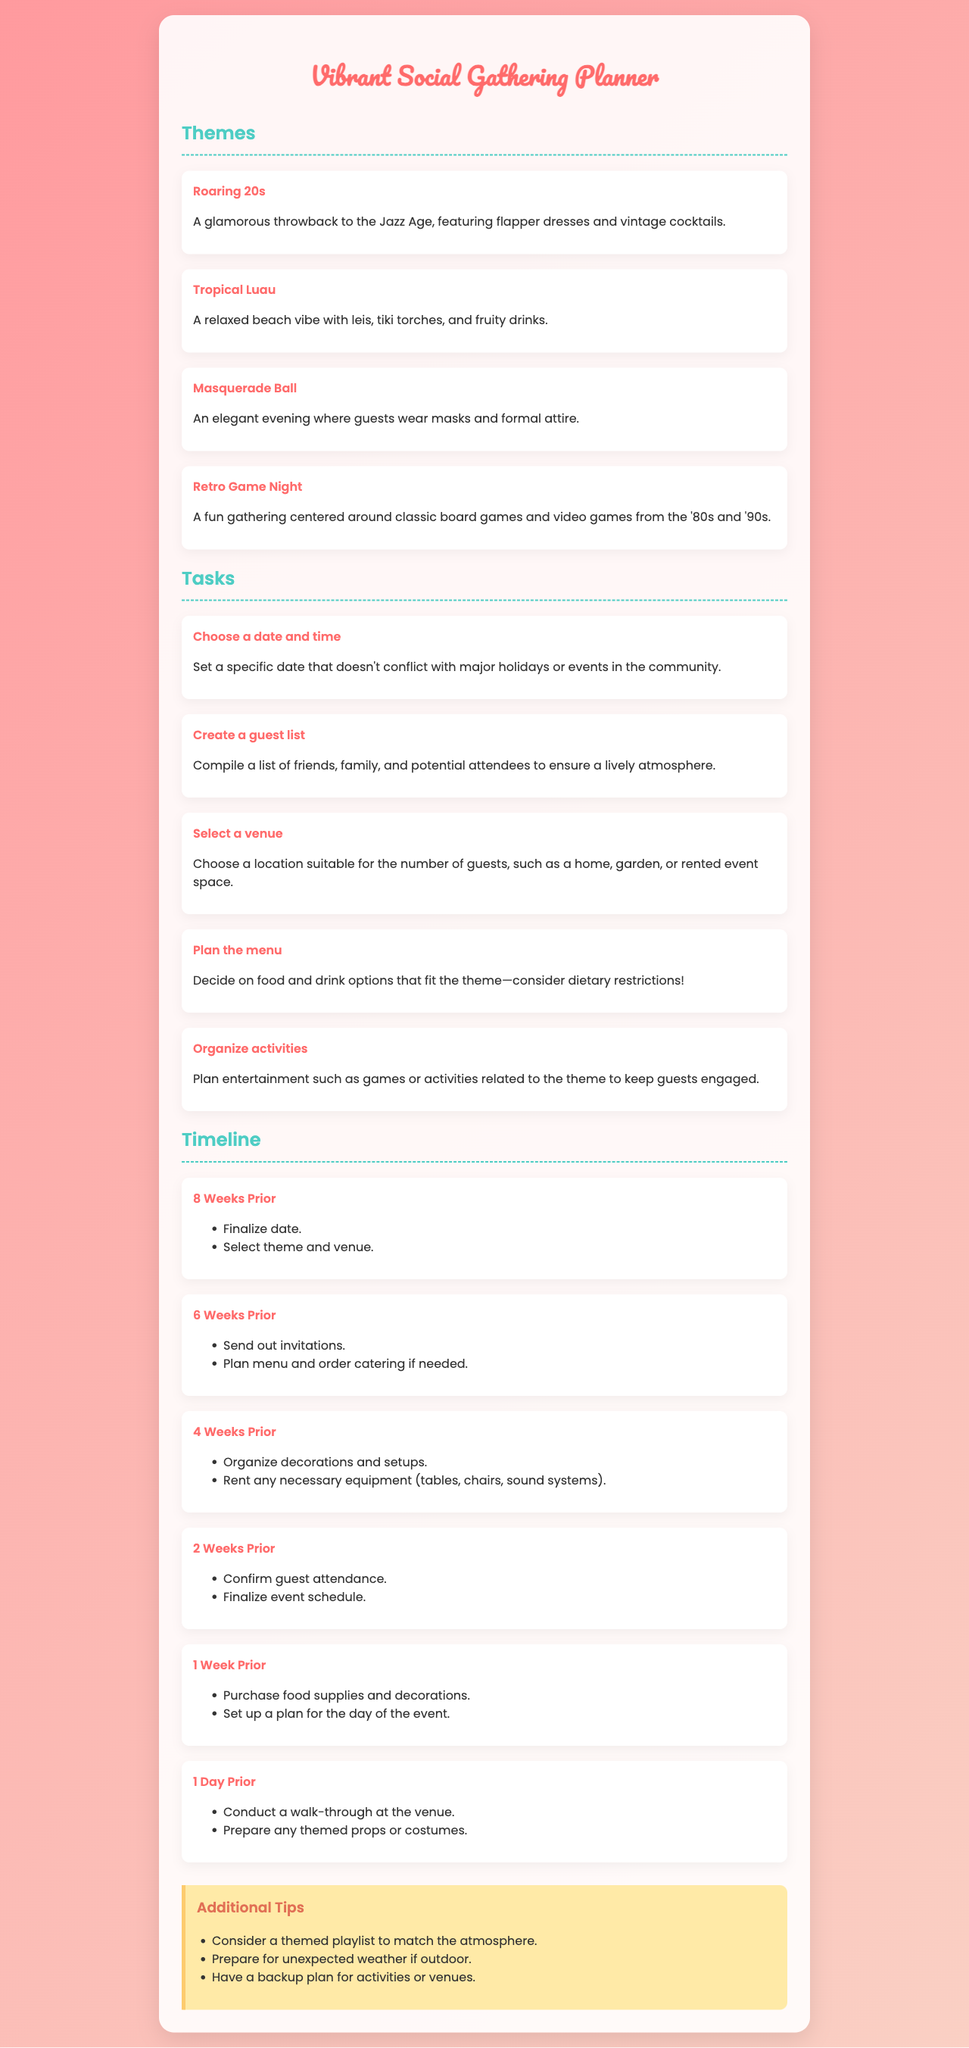What is one theme for the party? The document lists several themes for the gathering, including "Roaring 20s."
Answer: Roaring 20s What is a task to organize the event? The document provides tasks such as "Choose a date and time" for planning the gathering.
Answer: Choose a date and time How many weeks prior should invitations be sent out? According to the timeline, invitations should be sent out 6 weeks before the event.
Answer: 6 Weeks Prior What does the "Tropical Luau" theme suggest? The description of the "Tropical Luau" theme includes items like leis and tiki torches.
Answer: leis What are two activities to finalize 1 day before the event? The document mentions "Conduct a walk-through at the venue" and "Prepare any themed props or costumes."
Answer: Conduct a walk-through at the venue; Prepare any themed props or costumes What is one of the additional tips provided? The document suggests considering a themed playlist to match the atmosphere of the gathering.
Answer: Themed playlist What is the color of the header for the themes section? The document specifies that the theme header uses the color #4ecdc4.
Answer: #4ecdc4 What type of event is the "Masquerade Ball"? The Masquerade Ball is characterized as an elegant evening event requiring masks and formal attire.
Answer: Elegant evening 